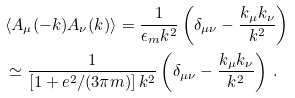Convert formula to latex. <formula><loc_0><loc_0><loc_500><loc_500>& \langle A _ { \mu } ( - k ) A _ { \nu } ( k ) \rangle = \frac { 1 } { \epsilon _ { m } k ^ { 2 } } \left ( \delta _ { \mu \nu } - \frac { k _ { \mu } k _ { \nu } } { k ^ { 2 } } \right ) \\ & \simeq \frac { 1 } { \left [ 1 + e ^ { 2 } / ( 3 \pi m ) \right ] k ^ { 2 } } \left ( \delta _ { \mu \nu } - \frac { k _ { \mu } k _ { \nu } } { k ^ { 2 } } \right ) \, .</formula> 